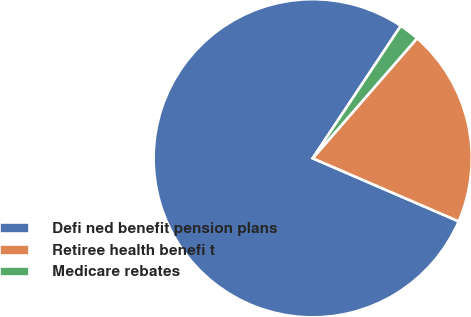Convert chart. <chart><loc_0><loc_0><loc_500><loc_500><pie_chart><fcel>Defi ned benefit pension plans<fcel>Retiree health benefi t<fcel>Medicare rebates<nl><fcel>77.86%<fcel>20.1%<fcel>2.05%<nl></chart> 